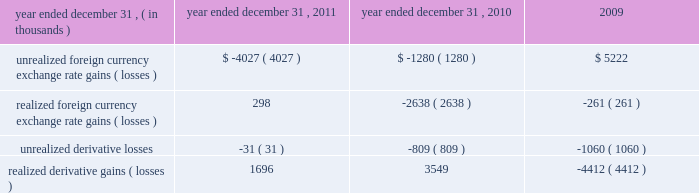From time to time , we may elect to use foreign currency forward contracts to reduce the risk from exchange rate fluctuations on intercompany transactions and projected inventory purchases for our european and canadian subsidiaries .
In addition , we may elect to enter into foreign currency forward contracts to reduce the risk associated with foreign currency exchange rate fluctuations on pound sterling denominated balance sheet items .
We do not enter into derivative financial instruments for speculative or trading purposes .
Based on the foreign currency forward contracts outstanding as of december 31 , 2011 , we receive u.s .
Dollars in exchange for canadian dollars at a weighted average contractual forward foreign currency exchange rate of 1.03 cad per $ 1.00 , u.s .
Dollars in exchange for euros at a weighted average contractual foreign currency exchange rate of 20ac0.77 per $ 1.00 and euros in exchange for pounds sterling at a weighted average contractual foreign currency exchange rate of a30.84 per 20ac1.00 .
As of december 31 , 2011 , the notional value of our outstanding foreign currency forward contracts for our canadian subsidiary was $ 51.1 million with contract maturities of 1 month or less , and the notional value of our outstanding foreign currency forward contracts for our european subsidiary was $ 50.0 million with contract maturities of 1 month .
As of december 31 , 2011 , the notional value of our outstanding foreign currency forward contract used to mitigate the foreign currency exchange rate fluctuations on pound sterling denominated balance sheet items was 20ac10.5 million , or $ 13.6 million , with a contract maturity of 1 month .
The foreign currency forward contracts are not designated as cash flow hedges , and accordingly , changes in their fair value are recorded in other expense , net on the consolidated statements of income .
The fair values of our foreign currency forward contracts were liabilities of $ 0.7 million and $ 0.6 million as of december 31 , 2011 and 2010 , respectively , and were included in accrued expenses on the consolidated balance sheet .
Refer to note 10 to the consolidated financial statements for a discussion of the fair value measurements .
Included in other expense , net were the following amounts related to changes in foreign currency exchange rates and derivative foreign currency forward contracts: .
We enter into foreign currency forward contracts with major financial institutions with investment grade credit ratings and are exposed to credit losses in the event of non-performance by these financial institutions .
This credit risk is generally limited to the unrealized gains in the foreign currency forward contracts .
However , we monitor the credit quality of these financial institutions and consider the risk of counterparty default to be minimal .
Although we have entered into foreign currency forward contracts to minimize some of the impact of foreign currency exchange rate fluctuations on future cash flows , we cannot be assured that foreign currency exchange rate fluctuations will not have a material adverse impact on our financial condition and results of operations .
Inflation inflationary factors such as increases in the cost of our product and overhead costs may adversely affect our operating results .
Although we do not believe that inflation has had a material impact on our financial position or results of operations to date , a high rate of inflation in the future may have an adverse effect on our ability to maintain current levels of gross margin and selling , general and administrative expenses as a percentage of net revenues if the selling prices of our products do not increase with these increased costs. .
What was the percent of the increase in the fair values of our foreign currency forward contracts liability from 2010 to 2011? 
Computations: ((0.7 - 0.6) / 0.6)
Answer: 0.16667. 